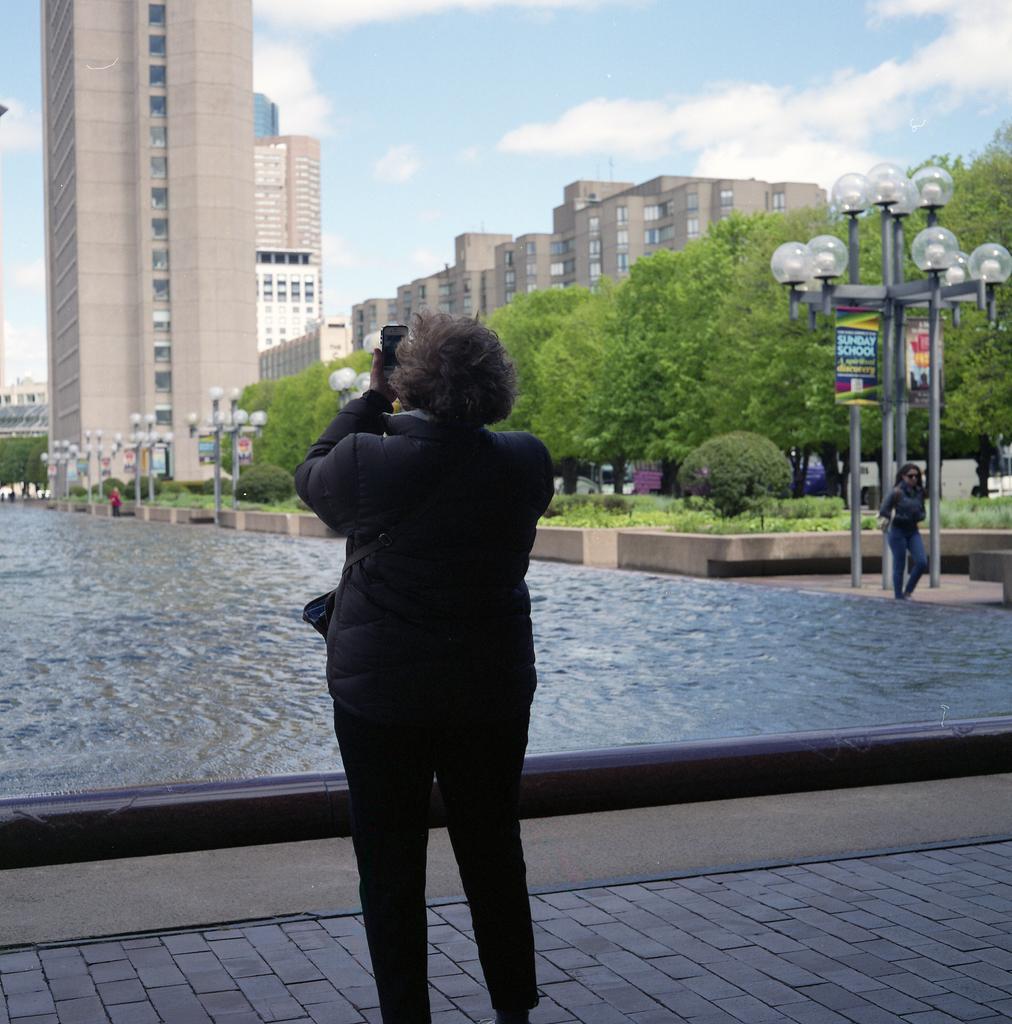Could you give a brief overview of what you see in this image? In this image, we can see some buildings, trees and lights. There are two persons standing and wearing clothes. There is a lake in the middle of the image. There is a sky at the top of the image. 